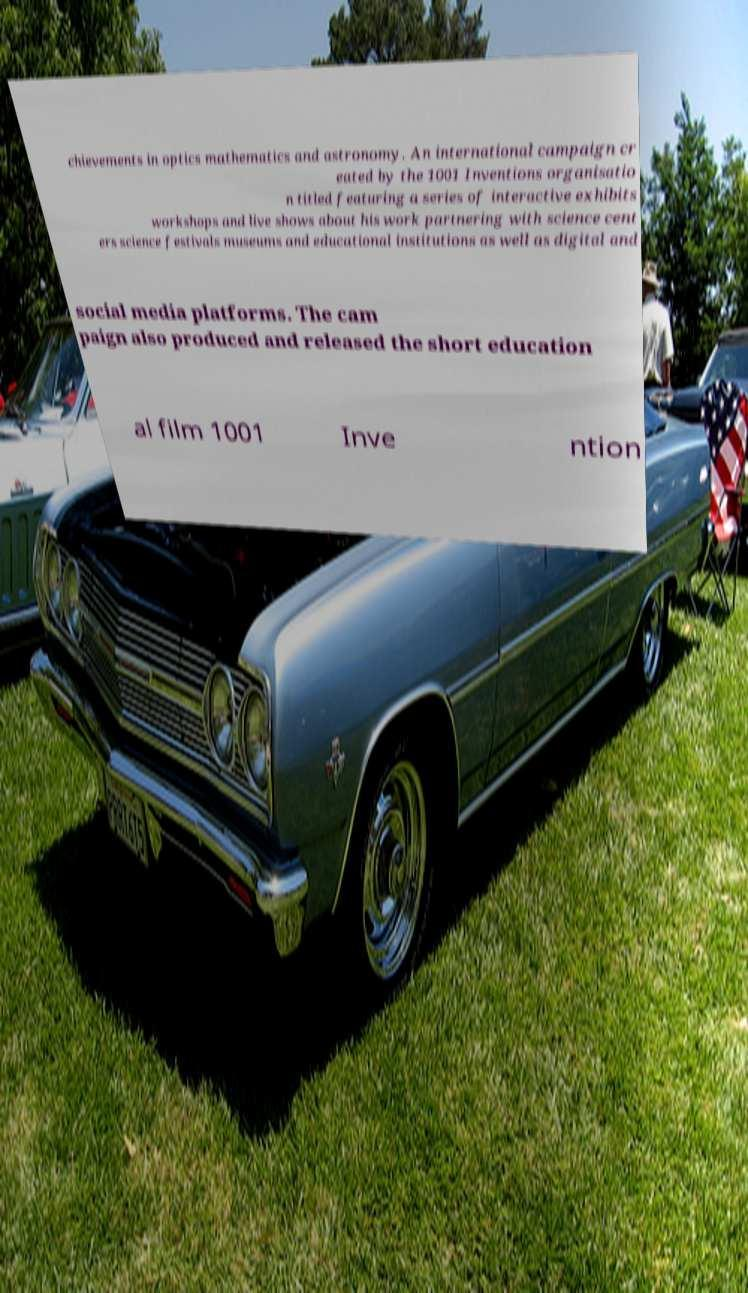Please read and relay the text visible in this image. What does it say? chievements in optics mathematics and astronomy. An international campaign cr eated by the 1001 Inventions organisatio n titled featuring a series of interactive exhibits workshops and live shows about his work partnering with science cent ers science festivals museums and educational institutions as well as digital and social media platforms. The cam paign also produced and released the short education al film 1001 Inve ntion 